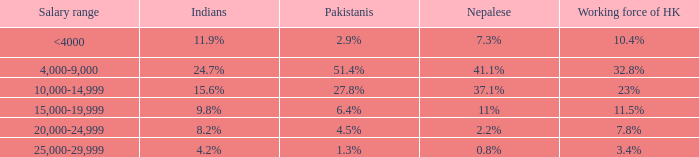If the nepalese is 37.1%, what is the working force of HK? 23%. 